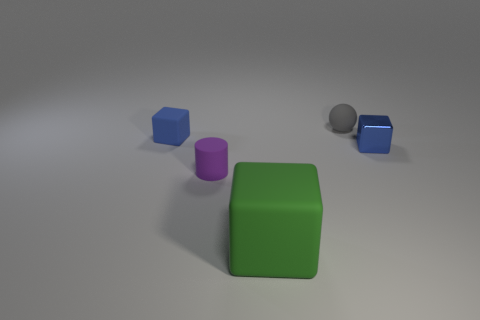What number of things are both right of the blue matte thing and in front of the tiny gray ball?
Give a very brief answer. 3. The other object that is the same color as the shiny object is what shape?
Your answer should be compact. Cube. There is a object that is to the right of the purple cylinder and to the left of the small gray ball; what is it made of?
Your answer should be very brief. Rubber. Are there fewer small objects in front of the rubber cylinder than rubber cubes that are to the right of the large green cube?
Make the answer very short. No. There is a green thing that is made of the same material as the small purple cylinder; what is its size?
Your answer should be compact. Large. Is there any other thing that is the same color as the small rubber sphere?
Your answer should be very brief. No. Are the green cube and the block that is to the right of the rubber sphere made of the same material?
Keep it short and to the point. No. There is another tiny blue thing that is the same shape as the blue rubber object; what is it made of?
Offer a terse response. Metal. Is the material of the small blue object that is on the left side of the big green object the same as the block that is right of the large block?
Your answer should be very brief. No. There is a tiny thing behind the blue block that is to the left of the shiny cube that is right of the large cube; what color is it?
Offer a terse response. Gray. 